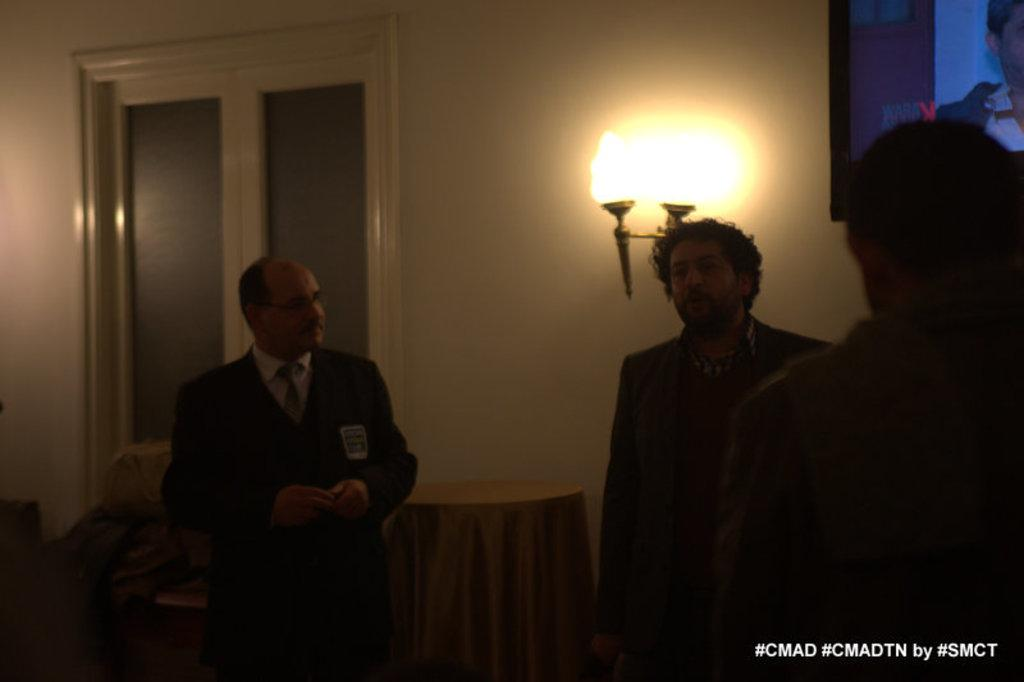How many people are in the image? There is a group of people in the image, but the exact number cannot be determined from the provided facts. What is present in the image besides the group of people? There is a table and lights on the wall in the image. Where are the lights located in the image? The lights are on the wall in the image. Is there any additional information about the image that is not directly related to its content? Yes, there is a watermark at the right bottom of the image. What type of marble is visible on the table in the image? There is no marble visible on the table in the image. Can you describe the ink used for the watermark at the right bottom of the image? The watermark is not described in terms of ink or any other material, so it is not possible to answer that question. 